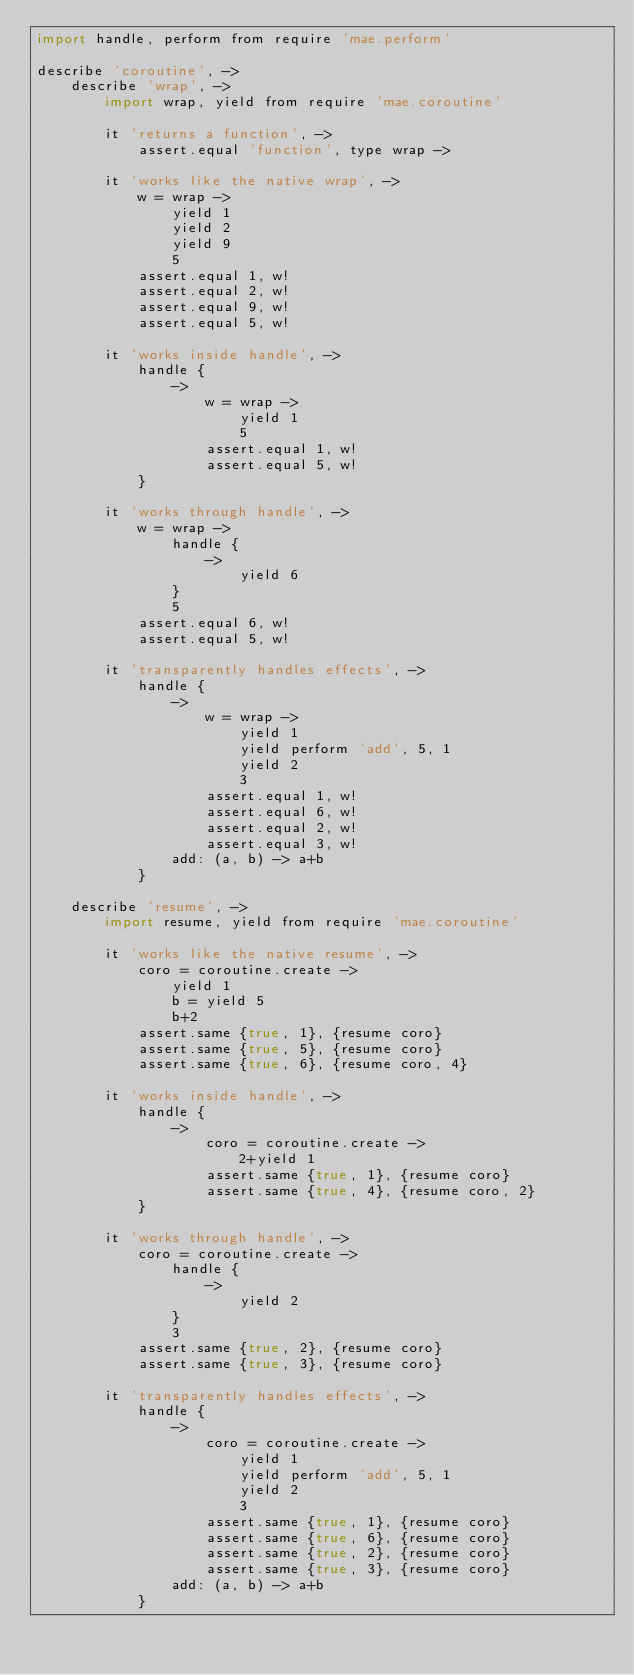Convert code to text. <code><loc_0><loc_0><loc_500><loc_500><_MoonScript_>import handle, perform from require 'mae.perform'

describe 'coroutine', ->
	describe 'wrap', ->
		import wrap, yield from require 'mae.coroutine'

		it 'returns a function', ->
			assert.equal 'function', type wrap ->

		it 'works like the native wrap', ->
			w = wrap ->
				yield 1
				yield 2
				yield 9
				5
			assert.equal 1, w!
			assert.equal 2, w!
			assert.equal 9, w!
			assert.equal 5, w!

		it 'works inside handle', ->
			handle {
				->
					w = wrap ->
						yield 1
						5
					assert.equal 1, w!
					assert.equal 5, w!
			}

		it 'works through handle', ->
			w = wrap ->
				handle {
					->
						yield 6
				}
				5
			assert.equal 6, w!
			assert.equal 5, w!

		it 'transparently handles effects', ->
			handle {
				->
					w = wrap ->
						yield 1
						yield perform 'add', 5, 1
						yield 2
						3
					assert.equal 1, w!
					assert.equal 6, w!
					assert.equal 2, w!
					assert.equal 3, w!
				add: (a, b) -> a+b
			}

	describe 'resume', ->
		import resume, yield from require 'mae.coroutine'

		it 'works like the native resume', ->
			coro = coroutine.create ->
				yield 1
				b = yield 5
				b+2
			assert.same {true, 1}, {resume coro}
			assert.same {true, 5}, {resume coro}
			assert.same {true, 6}, {resume coro, 4}

		it 'works inside handle', ->
			handle {
				->
					coro = coroutine.create ->
						2+yield 1
					assert.same {true, 1}, {resume coro}
					assert.same {true, 4}, {resume coro, 2}
			}

		it 'works through handle', ->
			coro = coroutine.create ->
				handle {
					->
						yield 2
				}
				3
			assert.same {true, 2}, {resume coro}
			assert.same {true, 3}, {resume coro}

		it 'transparently handles effects', ->
			handle {
				->
					coro = coroutine.create ->
						yield 1
						yield perform 'add', 5, 1
						yield 2
						3
					assert.same {true, 1}, {resume coro}
					assert.same {true, 6}, {resume coro}
					assert.same {true, 2}, {resume coro}
					assert.same {true, 3}, {resume coro}
				add: (a, b) -> a+b
			}

</code> 